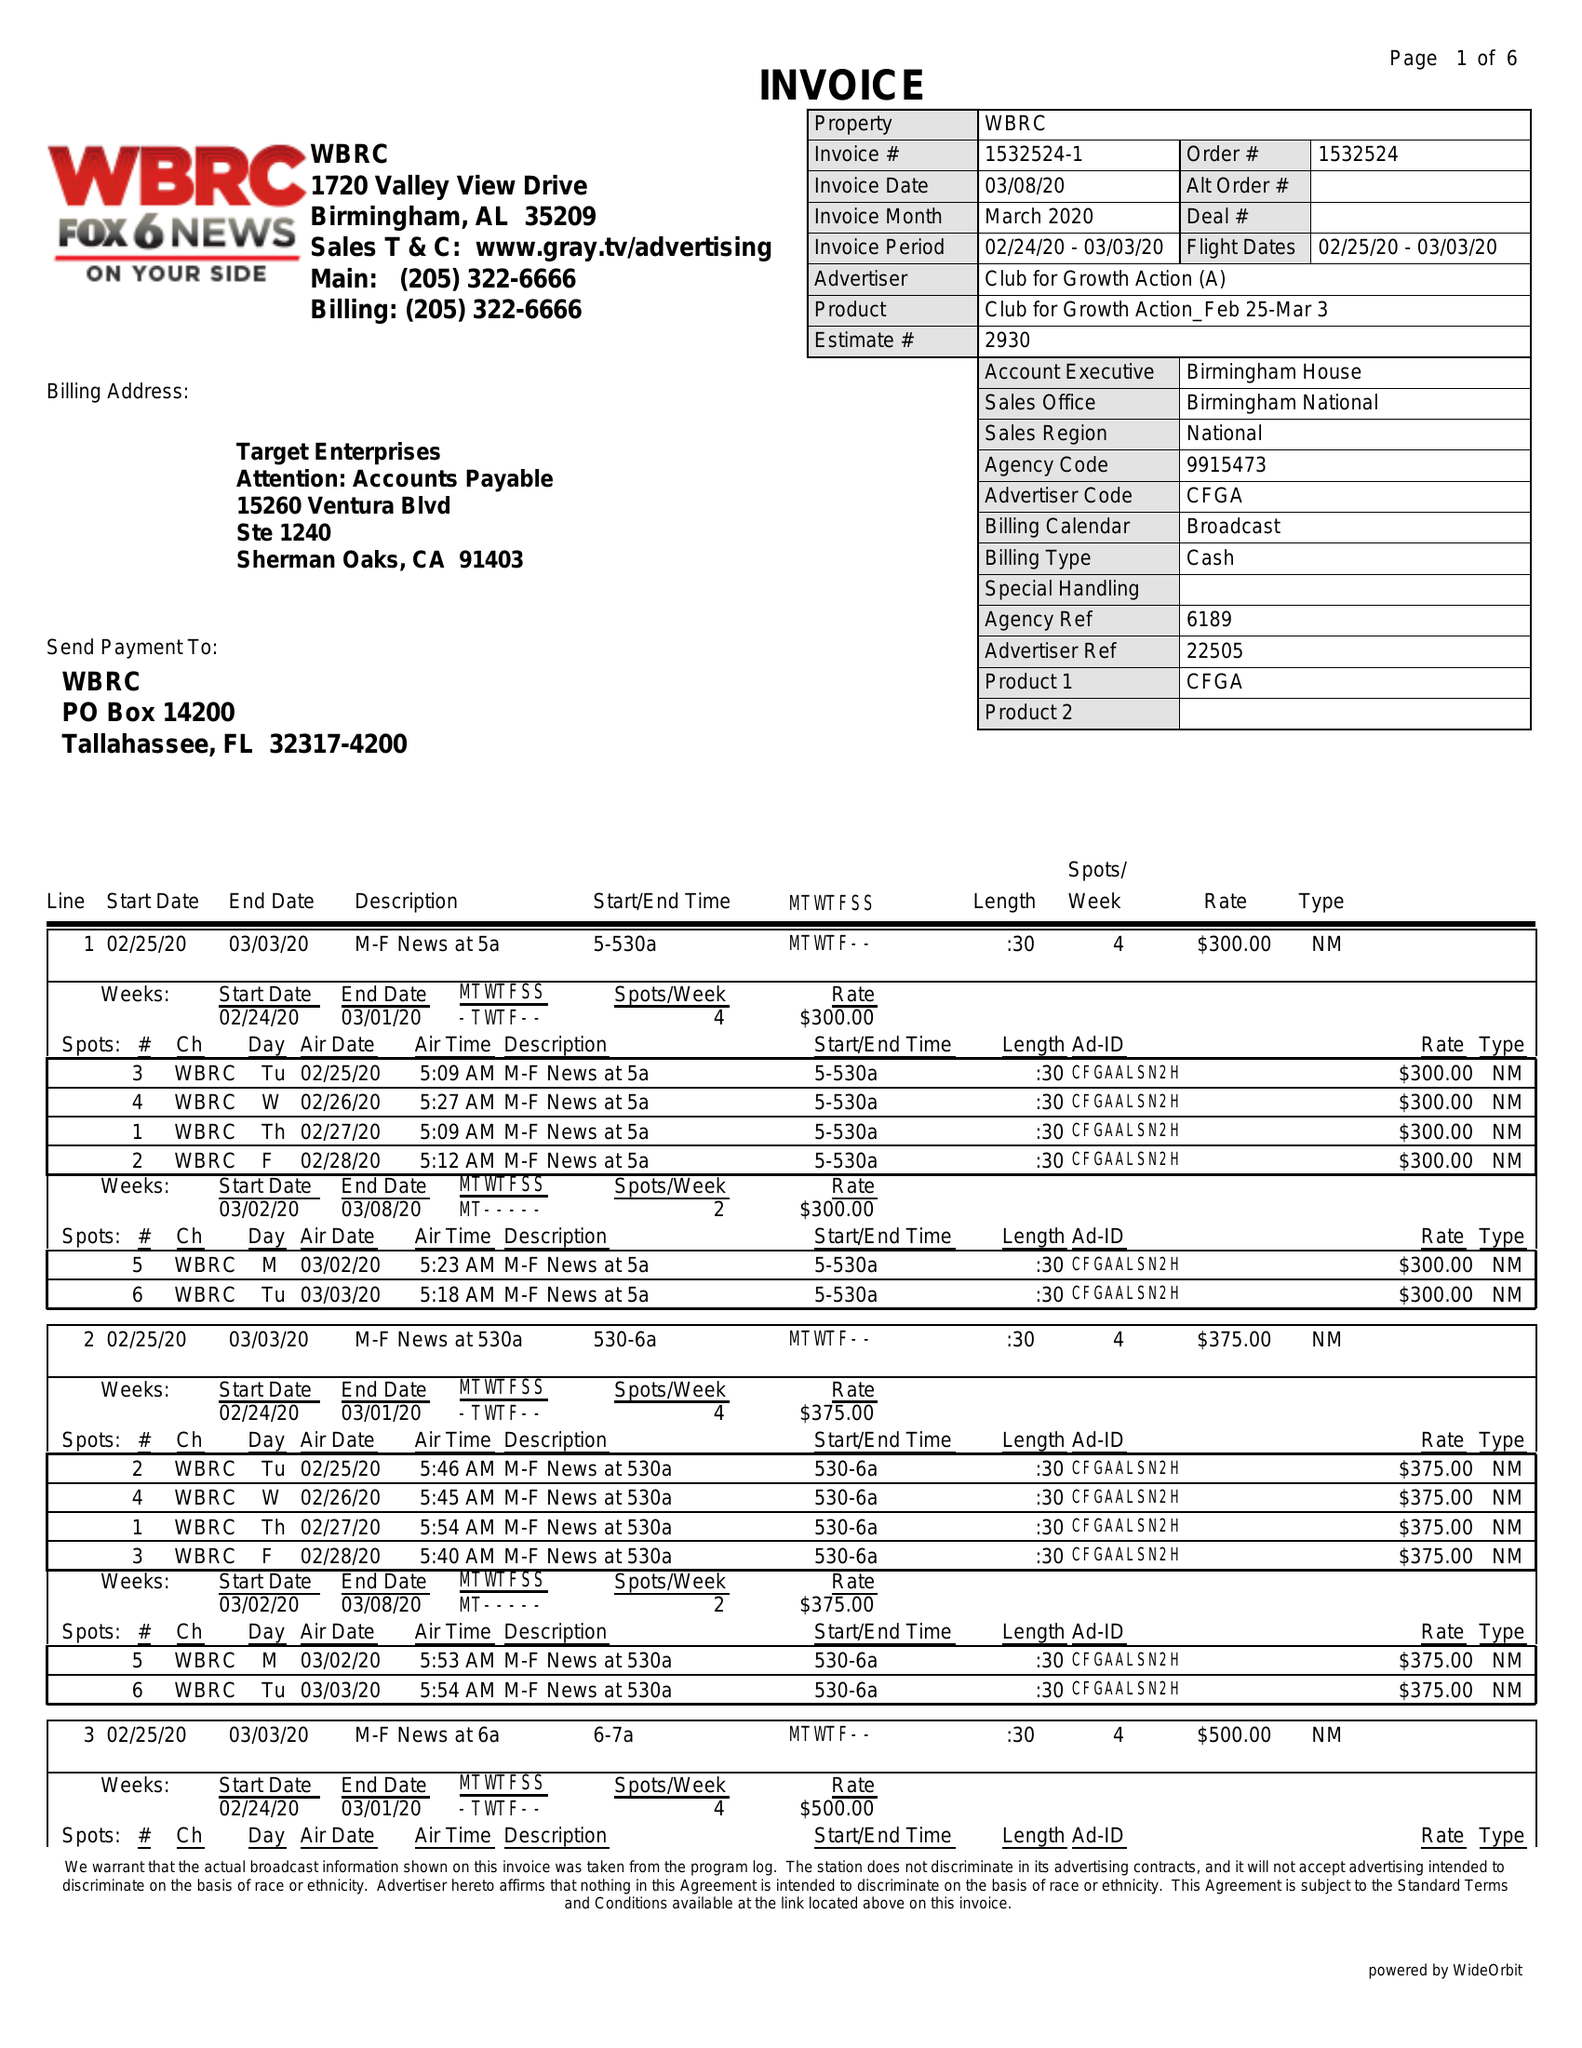What is the value for the flight_from?
Answer the question using a single word or phrase. 02/25/20 